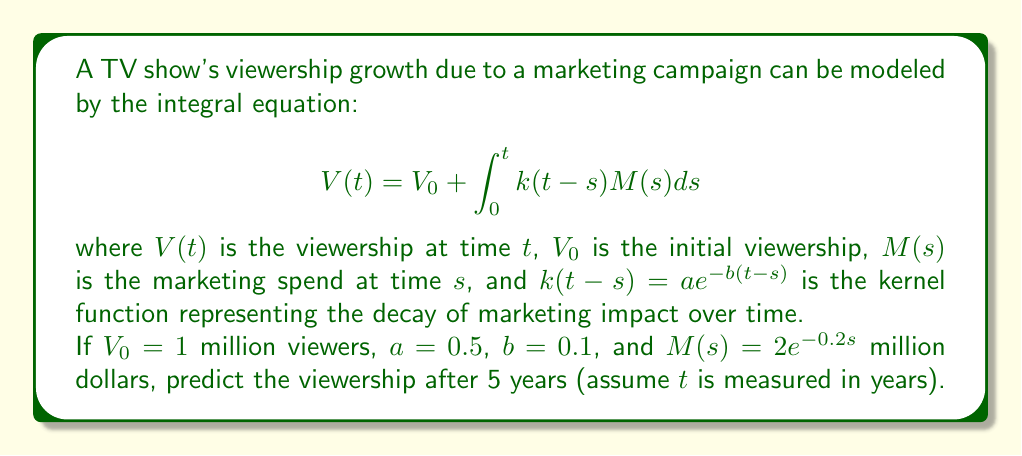Can you solve this math problem? To solve this problem, we need to evaluate the integral equation:

1) First, let's substitute the given values into the equation:

   $$V(5) = 1 + \int_0^5 0.5e^{-0.1(5-s)}(2e^{-0.2s})ds$$

2) Simplify the integrand:

   $$V(5) = 1 + \int_0^5 e^{-0.5+0.1s-0.2s}ds = 1 + \int_0^5 e^{-0.5-0.1s}ds$$

3) Evaluate the integral:

   $$V(5) = 1 + e^{-0.5} \int_0^5 e^{-0.1s}ds$$
   
   $$= 1 + e^{-0.5} \left[-10e^{-0.1s}\right]_0^5$$
   
   $$= 1 + e^{-0.5} \left[-10e^{-0.5} + 10\right]$$

4) Simplify:

   $$V(5) = 1 + 10e^{-0.5} - 10e^{-1}$$
   
   $$= 1 + 10(0.6065) - 10(0.3679)$$
   
   $$= 1 + 6.065 - 3.679$$
   
   $$= 3.386$$

Therefore, the predicted viewership after 5 years is approximately 3.386 million viewers.
Answer: 3.386 million viewers 